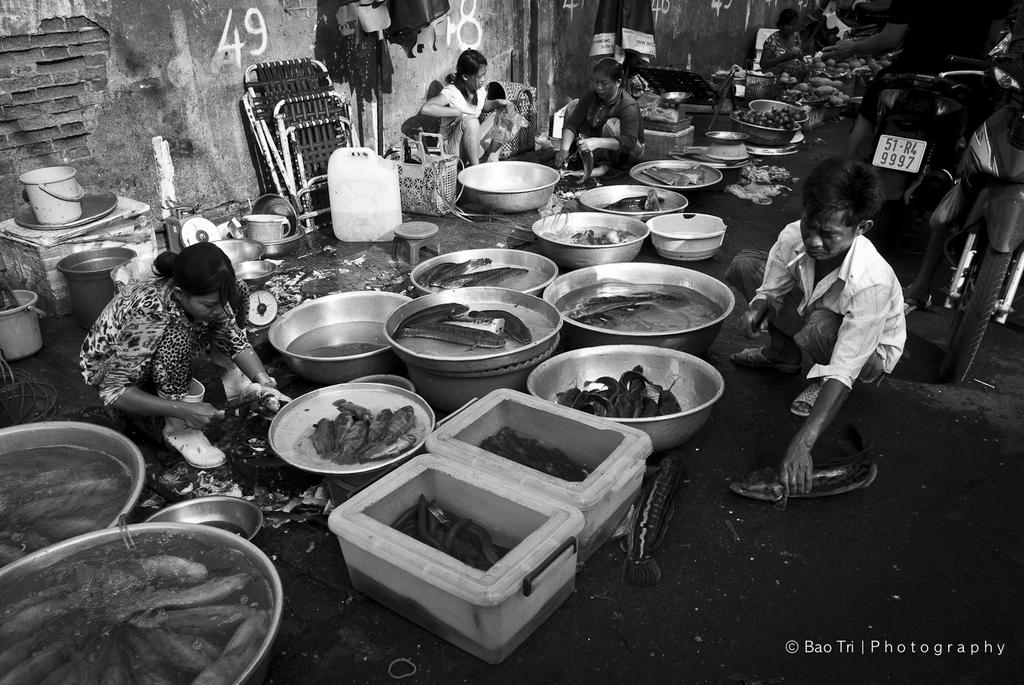What is the color scheme of the image? The image is black and white. What types of subjects are present in the image? There are people, vehicles, containers, fishes, a wall, and objects in the image. Can you describe the vehicles in the image? Unfortunately, the black and white nature of the image makes it difficult to discern specific details about the vehicles. What is the purpose of the containers in the image? The purpose of the containers is not clear from the image, but they may be used for storage or transportation. How many fishes are visible in the image? There are fishes in the image, but without more specific information, it is impossible to determine the exact number. How many people are touching the pocket in the image? There is no pocket visible in the image, so it is impossible to answer this question. 